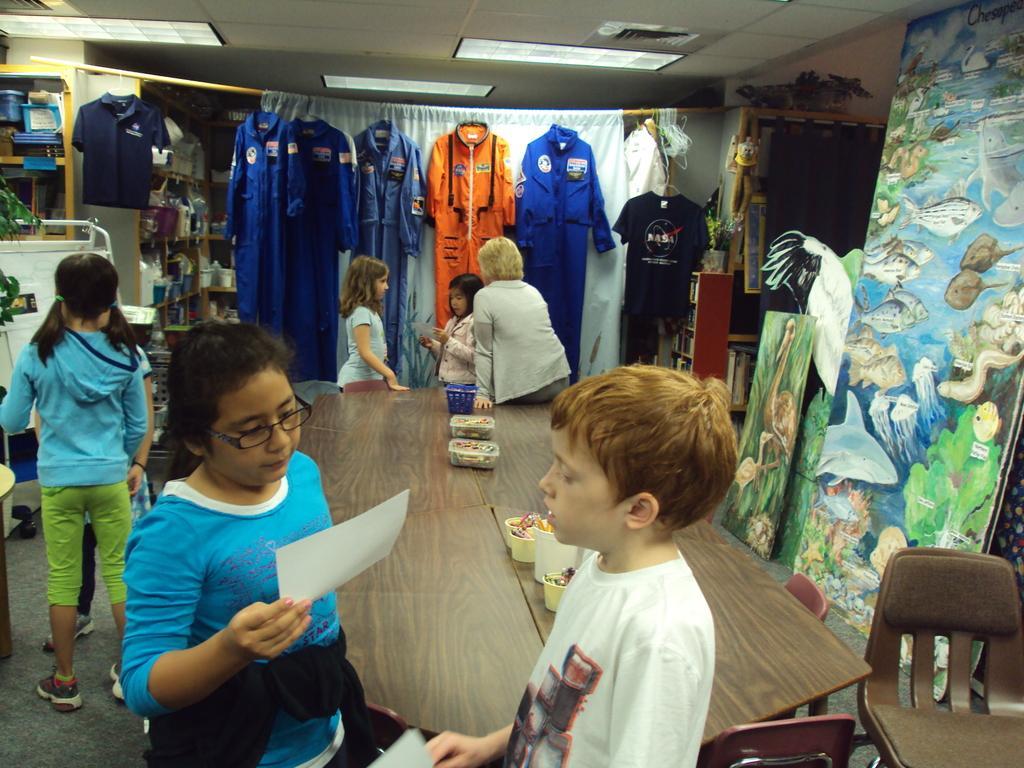Can you describe this image briefly? There are 6 kids at the table and 3 kids are holding paper in their hand and looking at the paper. On the table there are food items and bowls. A woman is sitting on the table. In the background there are clothes,curtain,hoardings,racks and lights. 